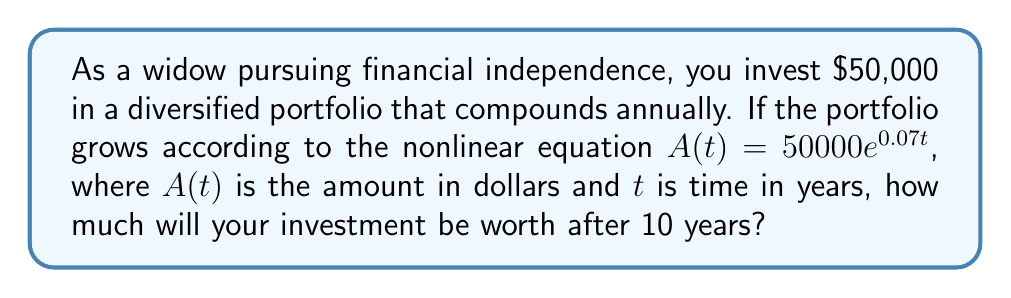Show me your answer to this math problem. To solve this problem, we'll follow these steps:

1. Identify the given information:
   - Initial investment: $50,000
   - Growth equation: $A(t) = 50000e^{0.07t}$
   - Time period: 10 years

2. Substitute the time value into the equation:
   $A(10) = 50000e^{0.07 \cdot 10}$

3. Simplify the exponent:
   $A(10) = 50000e^{0.7}$

4. Calculate the value of $e^{0.7}$:
   $e^{0.7} \approx 2.0137527074704755$

5. Multiply the result by the initial investment:
   $A(10) = 50000 \cdot 2.0137527074704755$

6. Compute the final value:
   $A(10) \approx 100687.63537352378$

Therefore, after 10 years, the investment will be worth approximately $100,687.64.
Answer: $100,687.64 